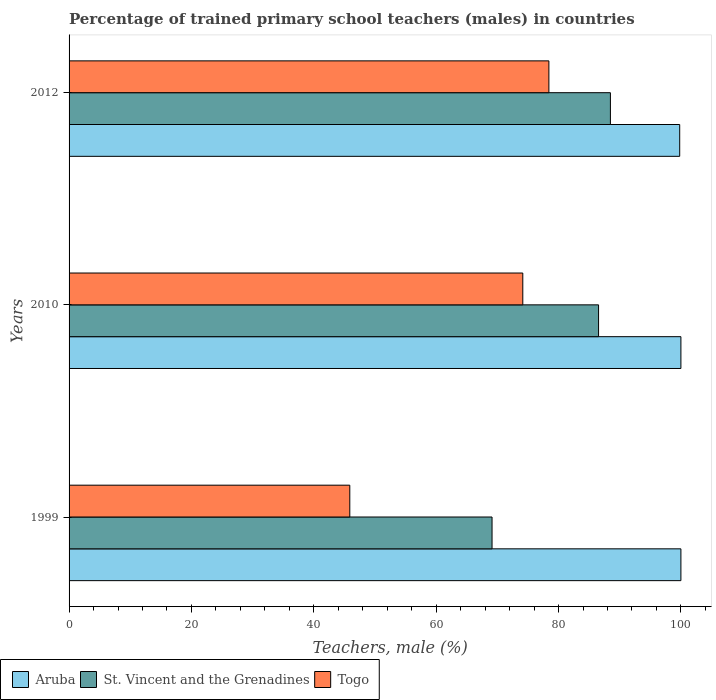How many different coloured bars are there?
Give a very brief answer. 3. How many groups of bars are there?
Ensure brevity in your answer.  3. Are the number of bars on each tick of the Y-axis equal?
Offer a terse response. Yes. How many bars are there on the 1st tick from the top?
Your answer should be very brief. 3. What is the label of the 3rd group of bars from the top?
Keep it short and to the point. 1999. In how many cases, is the number of bars for a given year not equal to the number of legend labels?
Give a very brief answer. 0. What is the percentage of trained primary school teachers (males) in Togo in 1999?
Provide a short and direct response. 45.88. Across all years, what is the maximum percentage of trained primary school teachers (males) in Aruba?
Offer a terse response. 100. Across all years, what is the minimum percentage of trained primary school teachers (males) in Togo?
Offer a terse response. 45.88. In which year was the percentage of trained primary school teachers (males) in St. Vincent and the Grenadines maximum?
Ensure brevity in your answer.  2012. In which year was the percentage of trained primary school teachers (males) in St. Vincent and the Grenadines minimum?
Give a very brief answer. 1999. What is the total percentage of trained primary school teachers (males) in Aruba in the graph?
Make the answer very short. 299.8. What is the difference between the percentage of trained primary school teachers (males) in Aruba in 1999 and that in 2012?
Keep it short and to the point. 0.2. What is the difference between the percentage of trained primary school teachers (males) in Aruba in 1999 and the percentage of trained primary school teachers (males) in Togo in 2012?
Make the answer very short. 21.58. What is the average percentage of trained primary school teachers (males) in Togo per year?
Your answer should be compact. 66.16. In the year 2010, what is the difference between the percentage of trained primary school teachers (males) in Togo and percentage of trained primary school teachers (males) in St. Vincent and the Grenadines?
Make the answer very short. -12.38. What is the ratio of the percentage of trained primary school teachers (males) in St. Vincent and the Grenadines in 2010 to that in 2012?
Make the answer very short. 0.98. Is the difference between the percentage of trained primary school teachers (males) in Togo in 2010 and 2012 greater than the difference between the percentage of trained primary school teachers (males) in St. Vincent and the Grenadines in 2010 and 2012?
Keep it short and to the point. No. What is the difference between the highest and the second highest percentage of trained primary school teachers (males) in St. Vincent and the Grenadines?
Your answer should be compact. 1.94. What is the difference between the highest and the lowest percentage of trained primary school teachers (males) in Togo?
Your answer should be very brief. 32.54. In how many years, is the percentage of trained primary school teachers (males) in Togo greater than the average percentage of trained primary school teachers (males) in Togo taken over all years?
Your answer should be very brief. 2. What does the 2nd bar from the top in 2010 represents?
Your answer should be compact. St. Vincent and the Grenadines. What does the 2nd bar from the bottom in 2012 represents?
Offer a terse response. St. Vincent and the Grenadines. How many years are there in the graph?
Offer a terse response. 3. Where does the legend appear in the graph?
Give a very brief answer. Bottom left. How are the legend labels stacked?
Provide a succinct answer. Horizontal. What is the title of the graph?
Ensure brevity in your answer.  Percentage of trained primary school teachers (males) in countries. Does "Ecuador" appear as one of the legend labels in the graph?
Offer a very short reply. No. What is the label or title of the X-axis?
Provide a short and direct response. Teachers, male (%). What is the Teachers, male (%) in St. Vincent and the Grenadines in 1999?
Provide a short and direct response. 69.13. What is the Teachers, male (%) in Togo in 1999?
Your answer should be very brief. 45.88. What is the Teachers, male (%) in St. Vincent and the Grenadines in 2010?
Keep it short and to the point. 86.54. What is the Teachers, male (%) of Togo in 2010?
Provide a succinct answer. 74.16. What is the Teachers, male (%) in Aruba in 2012?
Provide a short and direct response. 99.8. What is the Teachers, male (%) in St. Vincent and the Grenadines in 2012?
Make the answer very short. 88.48. What is the Teachers, male (%) of Togo in 2012?
Keep it short and to the point. 78.42. Across all years, what is the maximum Teachers, male (%) of Aruba?
Keep it short and to the point. 100. Across all years, what is the maximum Teachers, male (%) of St. Vincent and the Grenadines?
Offer a very short reply. 88.48. Across all years, what is the maximum Teachers, male (%) of Togo?
Your answer should be compact. 78.42. Across all years, what is the minimum Teachers, male (%) in Aruba?
Ensure brevity in your answer.  99.8. Across all years, what is the minimum Teachers, male (%) in St. Vincent and the Grenadines?
Give a very brief answer. 69.13. Across all years, what is the minimum Teachers, male (%) of Togo?
Your answer should be compact. 45.88. What is the total Teachers, male (%) in Aruba in the graph?
Make the answer very short. 299.8. What is the total Teachers, male (%) in St. Vincent and the Grenadines in the graph?
Offer a very short reply. 244.15. What is the total Teachers, male (%) of Togo in the graph?
Your response must be concise. 198.47. What is the difference between the Teachers, male (%) in Aruba in 1999 and that in 2010?
Your response must be concise. 0. What is the difference between the Teachers, male (%) in St. Vincent and the Grenadines in 1999 and that in 2010?
Your answer should be very brief. -17.41. What is the difference between the Teachers, male (%) in Togo in 1999 and that in 2010?
Your answer should be very brief. -28.28. What is the difference between the Teachers, male (%) of Aruba in 1999 and that in 2012?
Provide a succinct answer. 0.2. What is the difference between the Teachers, male (%) in St. Vincent and the Grenadines in 1999 and that in 2012?
Your answer should be compact. -19.35. What is the difference between the Teachers, male (%) of Togo in 1999 and that in 2012?
Provide a succinct answer. -32.54. What is the difference between the Teachers, male (%) in Aruba in 2010 and that in 2012?
Your answer should be compact. 0.2. What is the difference between the Teachers, male (%) of St. Vincent and the Grenadines in 2010 and that in 2012?
Give a very brief answer. -1.94. What is the difference between the Teachers, male (%) in Togo in 2010 and that in 2012?
Give a very brief answer. -4.26. What is the difference between the Teachers, male (%) of Aruba in 1999 and the Teachers, male (%) of St. Vincent and the Grenadines in 2010?
Your answer should be compact. 13.46. What is the difference between the Teachers, male (%) in Aruba in 1999 and the Teachers, male (%) in Togo in 2010?
Offer a very short reply. 25.84. What is the difference between the Teachers, male (%) of St. Vincent and the Grenadines in 1999 and the Teachers, male (%) of Togo in 2010?
Provide a succinct answer. -5.03. What is the difference between the Teachers, male (%) of Aruba in 1999 and the Teachers, male (%) of St. Vincent and the Grenadines in 2012?
Keep it short and to the point. 11.52. What is the difference between the Teachers, male (%) in Aruba in 1999 and the Teachers, male (%) in Togo in 2012?
Provide a succinct answer. 21.58. What is the difference between the Teachers, male (%) of St. Vincent and the Grenadines in 1999 and the Teachers, male (%) of Togo in 2012?
Make the answer very short. -9.29. What is the difference between the Teachers, male (%) of Aruba in 2010 and the Teachers, male (%) of St. Vincent and the Grenadines in 2012?
Offer a terse response. 11.52. What is the difference between the Teachers, male (%) in Aruba in 2010 and the Teachers, male (%) in Togo in 2012?
Make the answer very short. 21.58. What is the difference between the Teachers, male (%) in St. Vincent and the Grenadines in 2010 and the Teachers, male (%) in Togo in 2012?
Provide a short and direct response. 8.12. What is the average Teachers, male (%) of Aruba per year?
Give a very brief answer. 99.93. What is the average Teachers, male (%) in St. Vincent and the Grenadines per year?
Your answer should be very brief. 81.38. What is the average Teachers, male (%) of Togo per year?
Your answer should be very brief. 66.16. In the year 1999, what is the difference between the Teachers, male (%) of Aruba and Teachers, male (%) of St. Vincent and the Grenadines?
Your response must be concise. 30.87. In the year 1999, what is the difference between the Teachers, male (%) in Aruba and Teachers, male (%) in Togo?
Give a very brief answer. 54.12. In the year 1999, what is the difference between the Teachers, male (%) of St. Vincent and the Grenadines and Teachers, male (%) of Togo?
Give a very brief answer. 23.25. In the year 2010, what is the difference between the Teachers, male (%) in Aruba and Teachers, male (%) in St. Vincent and the Grenadines?
Offer a very short reply. 13.46. In the year 2010, what is the difference between the Teachers, male (%) in Aruba and Teachers, male (%) in Togo?
Offer a terse response. 25.84. In the year 2010, what is the difference between the Teachers, male (%) in St. Vincent and the Grenadines and Teachers, male (%) in Togo?
Your answer should be compact. 12.38. In the year 2012, what is the difference between the Teachers, male (%) in Aruba and Teachers, male (%) in St. Vincent and the Grenadines?
Make the answer very short. 11.33. In the year 2012, what is the difference between the Teachers, male (%) of Aruba and Teachers, male (%) of Togo?
Provide a succinct answer. 21.38. In the year 2012, what is the difference between the Teachers, male (%) in St. Vincent and the Grenadines and Teachers, male (%) in Togo?
Give a very brief answer. 10.05. What is the ratio of the Teachers, male (%) in Aruba in 1999 to that in 2010?
Provide a short and direct response. 1. What is the ratio of the Teachers, male (%) of St. Vincent and the Grenadines in 1999 to that in 2010?
Your response must be concise. 0.8. What is the ratio of the Teachers, male (%) of Togo in 1999 to that in 2010?
Offer a terse response. 0.62. What is the ratio of the Teachers, male (%) in St. Vincent and the Grenadines in 1999 to that in 2012?
Give a very brief answer. 0.78. What is the ratio of the Teachers, male (%) in Togo in 1999 to that in 2012?
Offer a very short reply. 0.59. What is the ratio of the Teachers, male (%) of St. Vincent and the Grenadines in 2010 to that in 2012?
Provide a short and direct response. 0.98. What is the ratio of the Teachers, male (%) in Togo in 2010 to that in 2012?
Your response must be concise. 0.95. What is the difference between the highest and the second highest Teachers, male (%) in St. Vincent and the Grenadines?
Keep it short and to the point. 1.94. What is the difference between the highest and the second highest Teachers, male (%) of Togo?
Provide a succinct answer. 4.26. What is the difference between the highest and the lowest Teachers, male (%) in Aruba?
Your response must be concise. 0.2. What is the difference between the highest and the lowest Teachers, male (%) in St. Vincent and the Grenadines?
Make the answer very short. 19.35. What is the difference between the highest and the lowest Teachers, male (%) of Togo?
Offer a terse response. 32.54. 